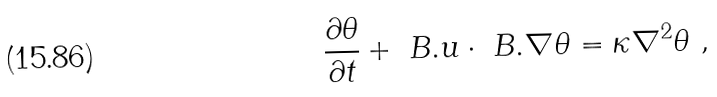Convert formula to latex. <formula><loc_0><loc_0><loc_500><loc_500>\frac { \partial \theta } { \partial t } + \ B . u \cdot \ B . \nabla \theta = \kappa \nabla ^ { 2 } \theta \ ,</formula> 